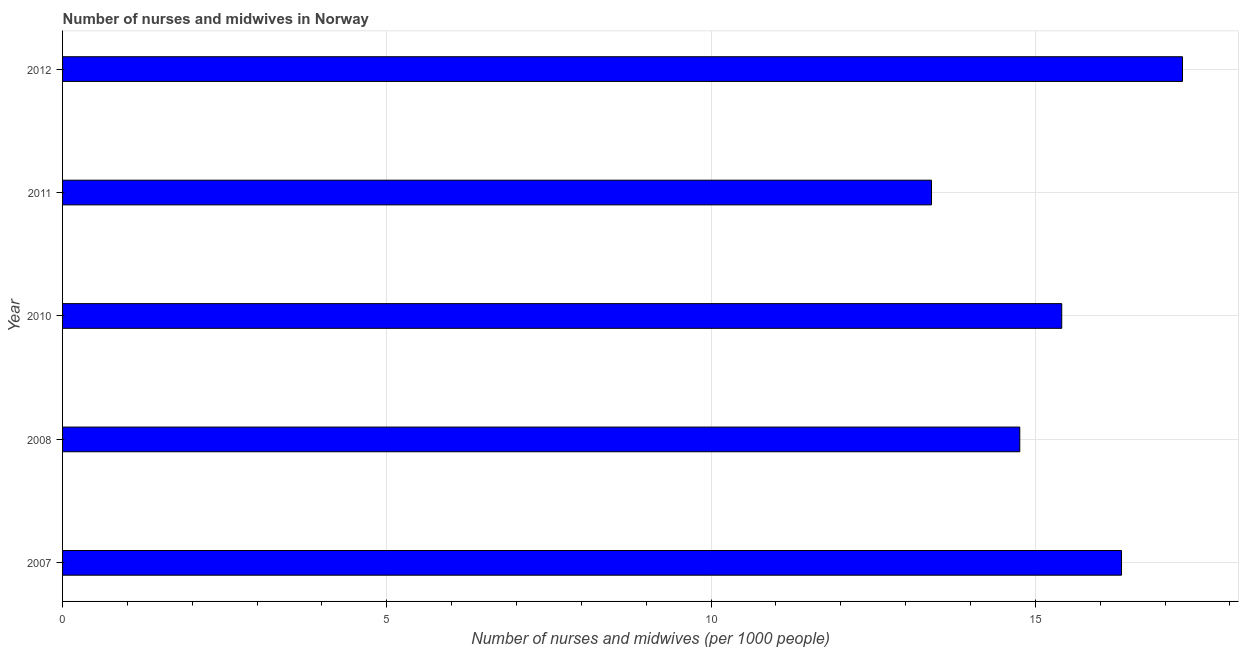Does the graph contain any zero values?
Give a very brief answer. No. What is the title of the graph?
Offer a very short reply. Number of nurses and midwives in Norway. What is the label or title of the X-axis?
Offer a very short reply. Number of nurses and midwives (per 1000 people). What is the label or title of the Y-axis?
Ensure brevity in your answer.  Year. What is the number of nurses and midwives in 2010?
Offer a very short reply. 15.41. Across all years, what is the maximum number of nurses and midwives?
Give a very brief answer. 17.27. Across all years, what is the minimum number of nurses and midwives?
Ensure brevity in your answer.  13.4. In which year was the number of nurses and midwives maximum?
Your answer should be very brief. 2012. What is the sum of the number of nurses and midwives?
Your answer should be compact. 77.16. What is the difference between the number of nurses and midwives in 2010 and 2011?
Make the answer very short. 2.01. What is the average number of nurses and midwives per year?
Provide a succinct answer. 15.43. What is the median number of nurses and midwives?
Provide a short and direct response. 15.41. Do a majority of the years between 2008 and 2007 (inclusive) have number of nurses and midwives greater than 12 ?
Make the answer very short. No. What is the ratio of the number of nurses and midwives in 2008 to that in 2010?
Offer a very short reply. 0.96. What is the difference between the highest and the lowest number of nurses and midwives?
Ensure brevity in your answer.  3.87. In how many years, is the number of nurses and midwives greater than the average number of nurses and midwives taken over all years?
Provide a succinct answer. 2. How many years are there in the graph?
Offer a terse response. 5. What is the difference between two consecutive major ticks on the X-axis?
Give a very brief answer. 5. What is the Number of nurses and midwives (per 1000 people) in 2007?
Provide a short and direct response. 16.33. What is the Number of nurses and midwives (per 1000 people) in 2008?
Provide a succinct answer. 14.76. What is the Number of nurses and midwives (per 1000 people) of 2010?
Ensure brevity in your answer.  15.41. What is the Number of nurses and midwives (per 1000 people) in 2011?
Your response must be concise. 13.4. What is the Number of nurses and midwives (per 1000 people) in 2012?
Offer a very short reply. 17.27. What is the difference between the Number of nurses and midwives (per 1000 people) in 2007 and 2008?
Your answer should be compact. 1.57. What is the difference between the Number of nurses and midwives (per 1000 people) in 2007 and 2010?
Give a very brief answer. 0.92. What is the difference between the Number of nurses and midwives (per 1000 people) in 2007 and 2011?
Your answer should be very brief. 2.93. What is the difference between the Number of nurses and midwives (per 1000 people) in 2007 and 2012?
Ensure brevity in your answer.  -0.94. What is the difference between the Number of nurses and midwives (per 1000 people) in 2008 and 2010?
Give a very brief answer. -0.65. What is the difference between the Number of nurses and midwives (per 1000 people) in 2008 and 2011?
Provide a short and direct response. 1.36. What is the difference between the Number of nurses and midwives (per 1000 people) in 2008 and 2012?
Make the answer very short. -2.51. What is the difference between the Number of nurses and midwives (per 1000 people) in 2010 and 2011?
Offer a terse response. 2.01. What is the difference between the Number of nurses and midwives (per 1000 people) in 2010 and 2012?
Give a very brief answer. -1.86. What is the difference between the Number of nurses and midwives (per 1000 people) in 2011 and 2012?
Your answer should be compact. -3.87. What is the ratio of the Number of nurses and midwives (per 1000 people) in 2007 to that in 2008?
Give a very brief answer. 1.11. What is the ratio of the Number of nurses and midwives (per 1000 people) in 2007 to that in 2010?
Ensure brevity in your answer.  1.06. What is the ratio of the Number of nurses and midwives (per 1000 people) in 2007 to that in 2011?
Your response must be concise. 1.22. What is the ratio of the Number of nurses and midwives (per 1000 people) in 2007 to that in 2012?
Provide a short and direct response. 0.95. What is the ratio of the Number of nurses and midwives (per 1000 people) in 2008 to that in 2010?
Keep it short and to the point. 0.96. What is the ratio of the Number of nurses and midwives (per 1000 people) in 2008 to that in 2011?
Provide a short and direct response. 1.1. What is the ratio of the Number of nurses and midwives (per 1000 people) in 2008 to that in 2012?
Give a very brief answer. 0.85. What is the ratio of the Number of nurses and midwives (per 1000 people) in 2010 to that in 2011?
Your answer should be compact. 1.15. What is the ratio of the Number of nurses and midwives (per 1000 people) in 2010 to that in 2012?
Your answer should be very brief. 0.89. What is the ratio of the Number of nurses and midwives (per 1000 people) in 2011 to that in 2012?
Offer a very short reply. 0.78. 